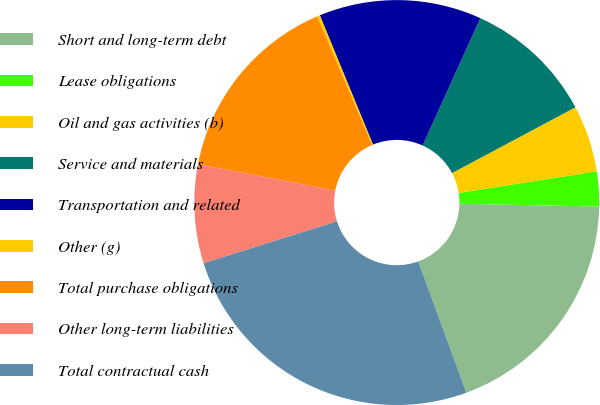Convert chart to OTSL. <chart><loc_0><loc_0><loc_500><loc_500><pie_chart><fcel>Short and long-term debt<fcel>Lease obligations<fcel>Oil and gas activities (b)<fcel>Service and materials<fcel>Transportation and related<fcel>Other (g)<fcel>Total purchase obligations<fcel>Other long-term liabilities<fcel>Total contractual cash<nl><fcel>19.11%<fcel>2.78%<fcel>5.33%<fcel>10.43%<fcel>12.98%<fcel>0.23%<fcel>15.53%<fcel>7.88%<fcel>25.74%<nl></chart> 